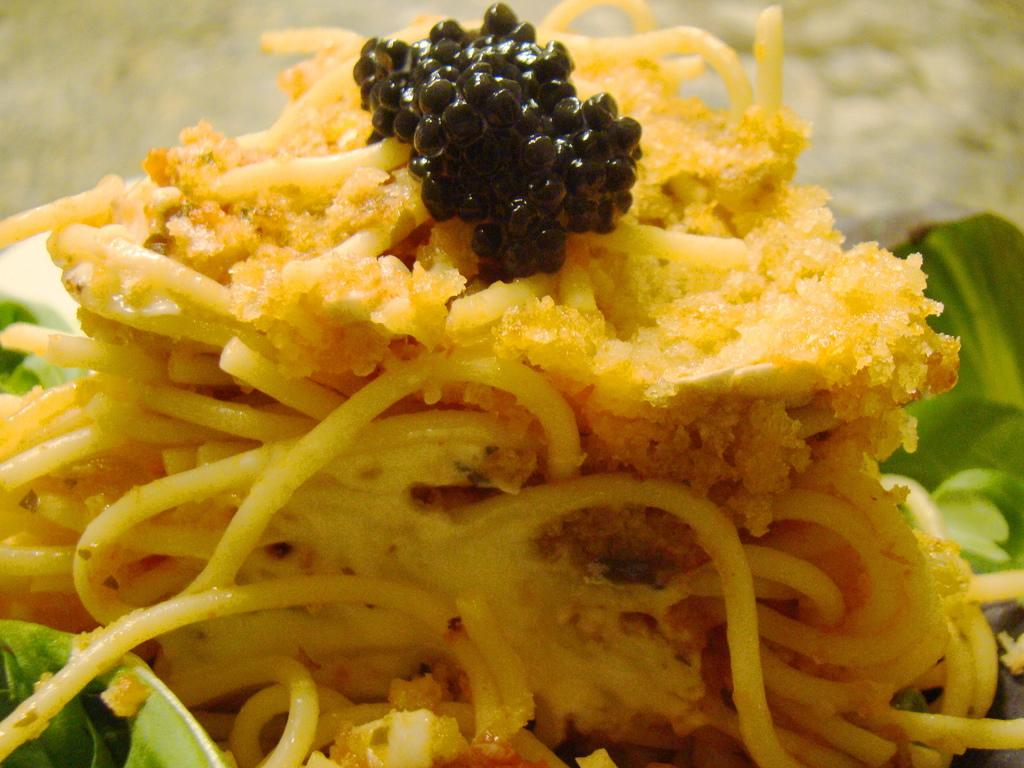What type of food is the main subject of the image? There are noodles in the image. Are there any other food items present besides the noodles? Yes, there are other food items in the image. Can you describe one of the food items in the image? There is a black color food item in the image. What type of vegetation can be seen in the image? There are green leaves in the image. What type of flesh can be seen attacking the noodles in the image? There is no flesh or attack depicted in the image; it features noodles and other food items. What type of board is used to serve the food in the image? There is no board present in the image; the food items are not shown on a board. 